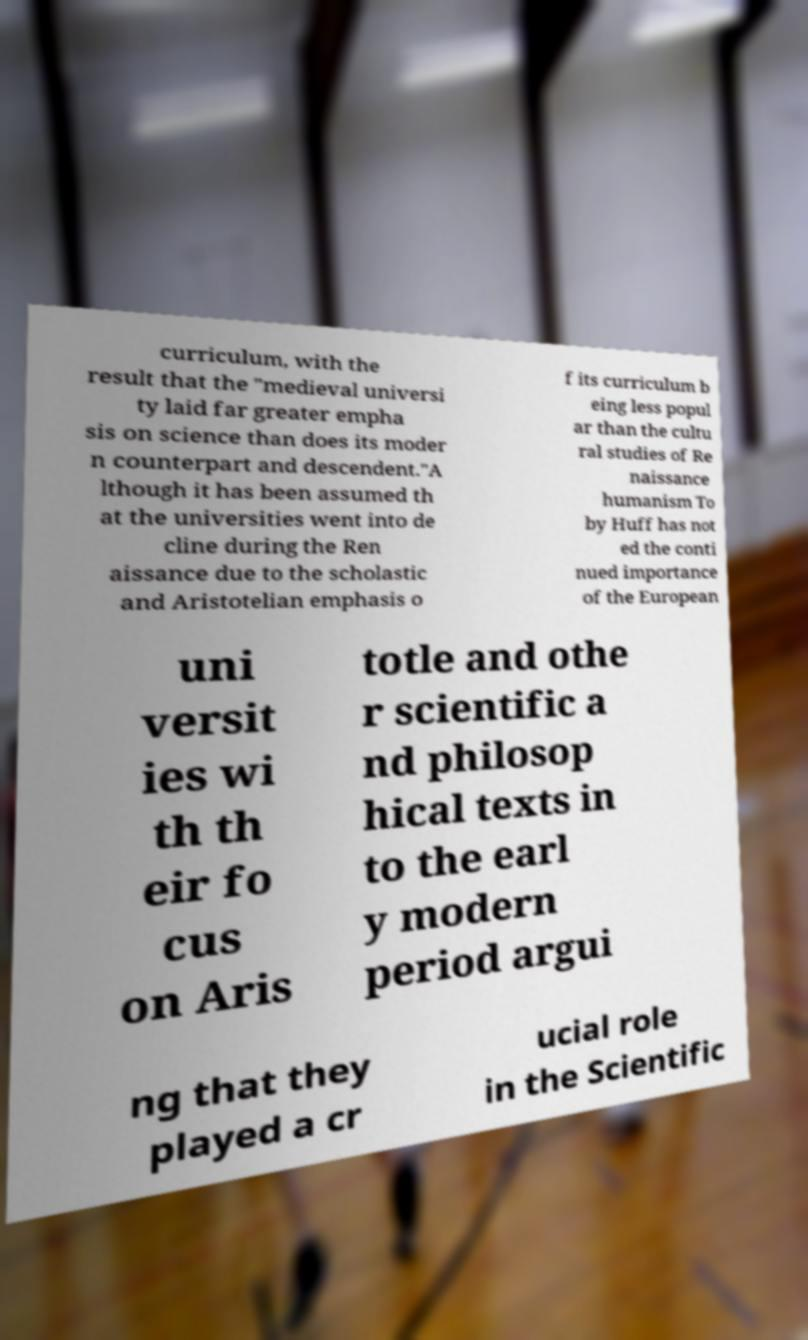There's text embedded in this image that I need extracted. Can you transcribe it verbatim? curriculum, with the result that the "medieval universi ty laid far greater empha sis on science than does its moder n counterpart and descendent."A lthough it has been assumed th at the universities went into de cline during the Ren aissance due to the scholastic and Aristotelian emphasis o f its curriculum b eing less popul ar than the cultu ral studies of Re naissance humanism To by Huff has not ed the conti nued importance of the European uni versit ies wi th th eir fo cus on Aris totle and othe r scientific a nd philosop hical texts in to the earl y modern period argui ng that they played a cr ucial role in the Scientific 